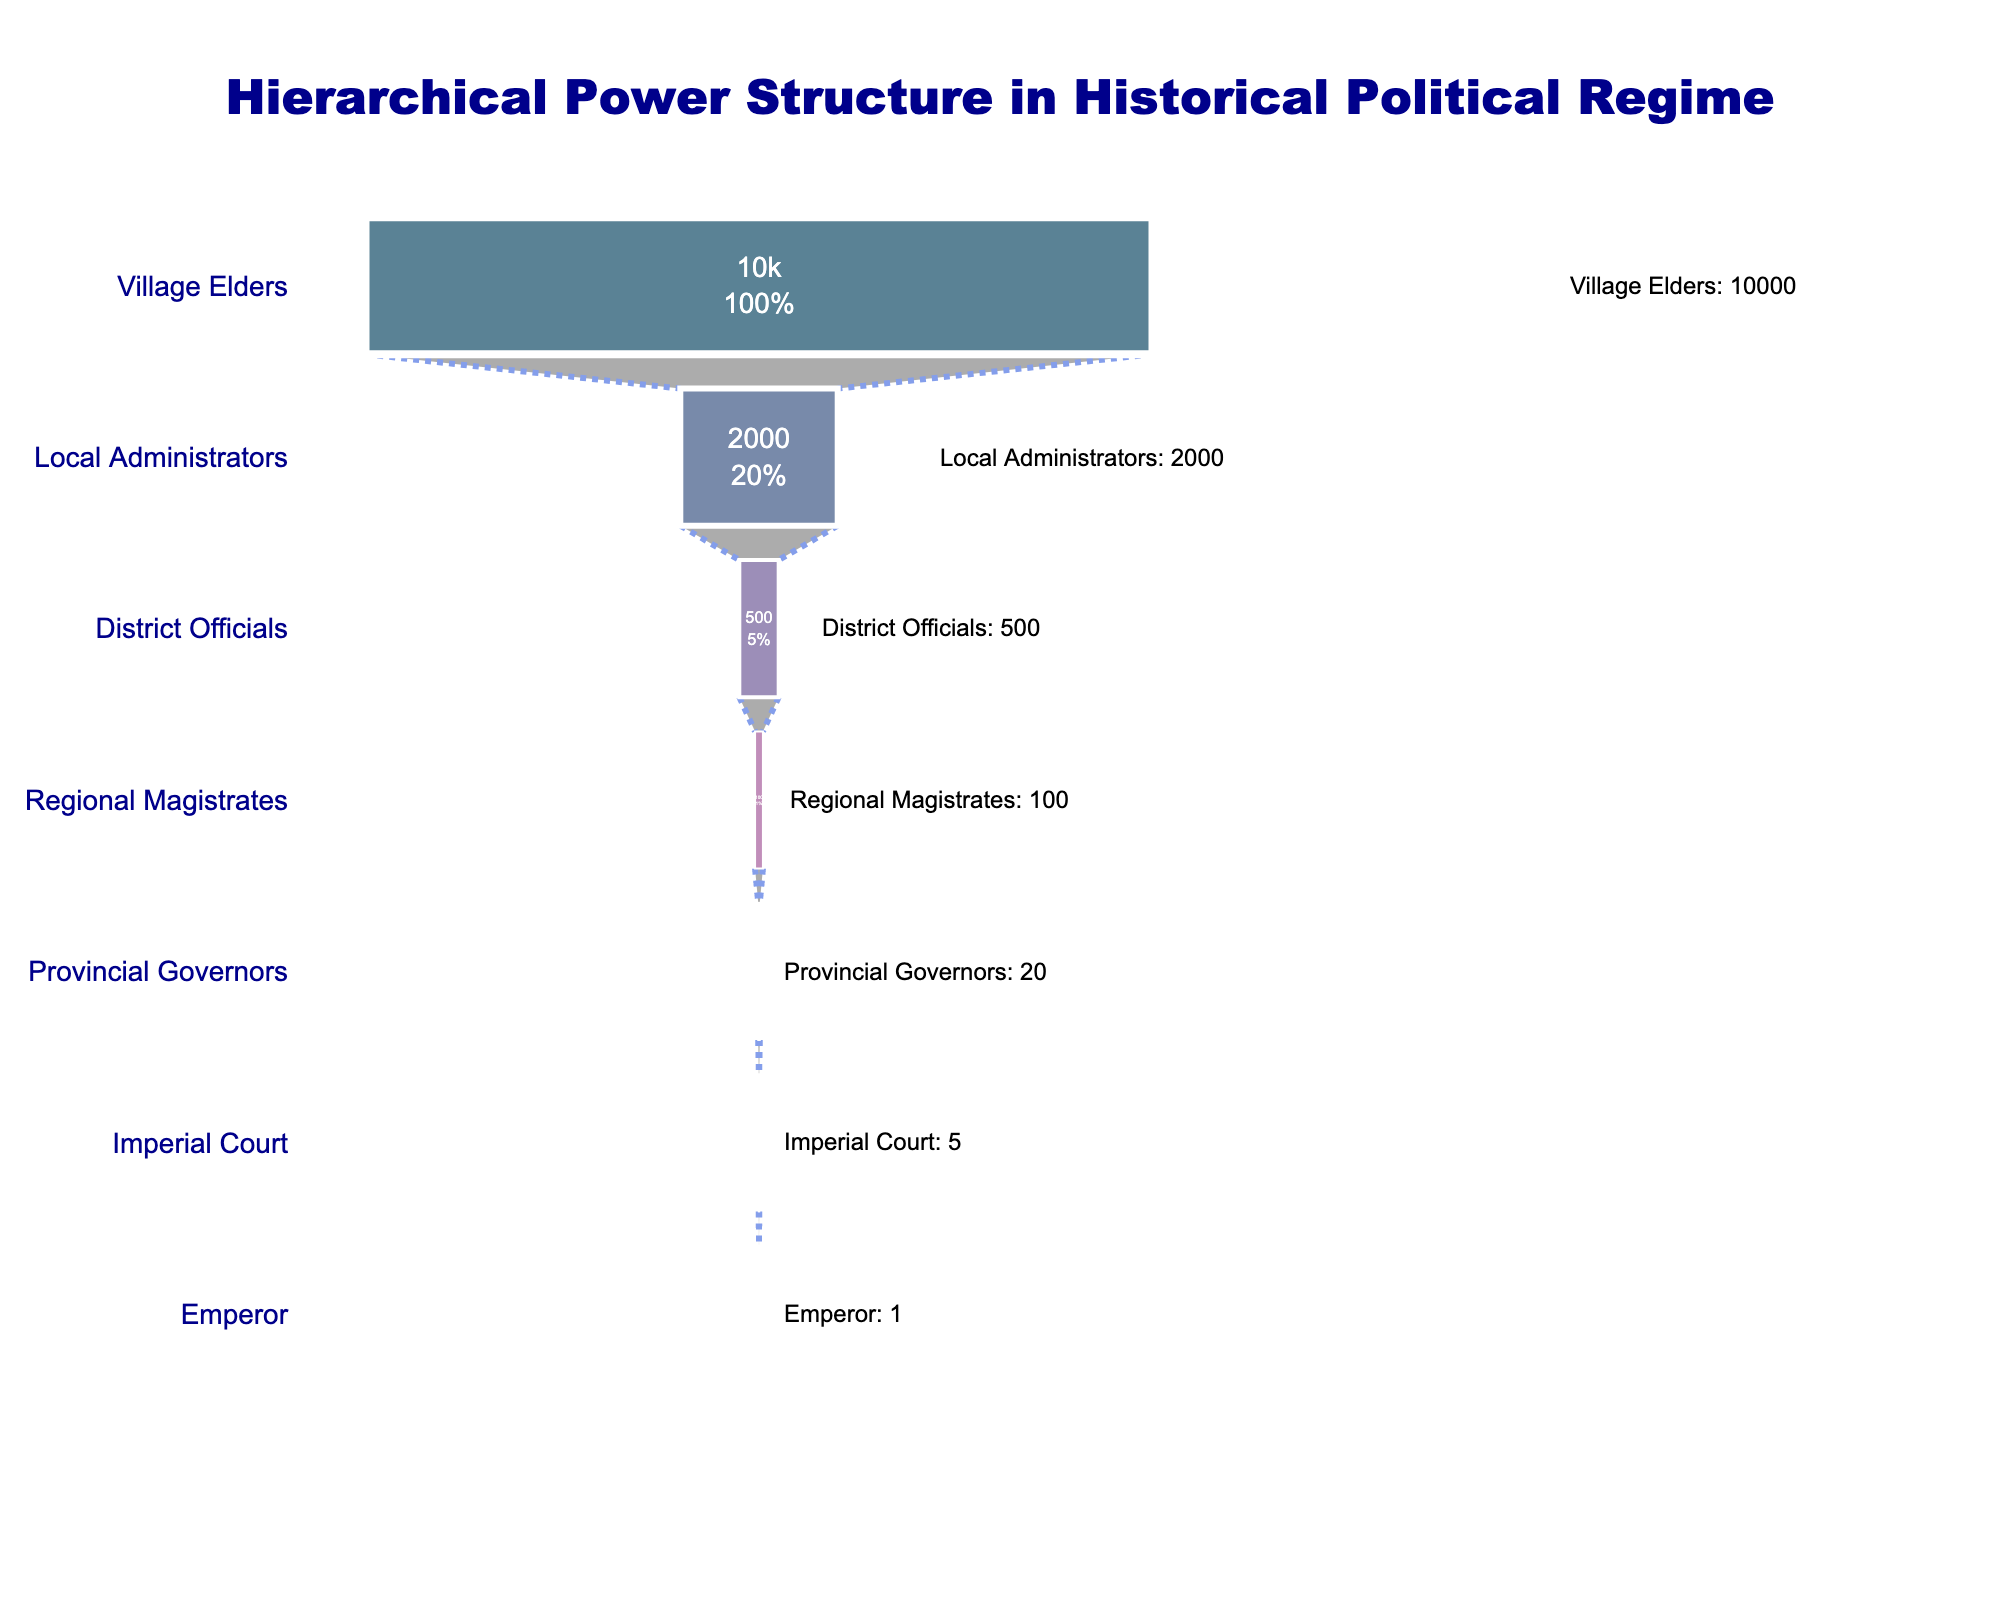How many levels are there in the hierarchical power structure? The title indicates that the plot represents a hierarchical power structure. By counting the distinct positions listed along the y-axis, we can ascertain the total number of levels. There are seven positions from Emperor to Village Elders.
Answer: 7 Which level has the highest number of individuals? By observing the funnel, the widest section at the bottom displays the highest number of individuals. This is the Village Elders level, which shows 10,000 individuals.
Answer: Village Elders What percentage of the total individuals does the Imperial Court represent? Starting from the top, note that the Imperial Court's section shows a percentage. Calculating this manually involves dividing the Imperial Court's 5 individuals by the total (sum of all levels: 12,626), then multiplying by 100.
Answer: 0.04% How many more District Officials are there compared to Regional Magistrates? Compare the numbers for District Officials (500) and Regional Magistrates (100) by subtracting the number of Regional Magistrates from District Officials. This results in 500 - 100 = 400.
Answer: 400 Which level has more individuals: Provincial Governors or Local Administrators? From the graphical depiction, the width of the respective sections and annotated numbers show that Local Administrators (2,000) outnumber Provincial Governors (20).
Answer: Local Administrators What is the sum of individuals from the Emperor to the Imperial Court inclusive? Adding the number of individuals in the Emperor (1) and the Imperial Court (5) levels results in 1 + 5 = 6.
Answer: 6 How many individuals are there between the Provincial Governors and the District Officials combined? Adding the individuals at the Provincial Governors (20), Regional Magistrates (100), and District Officials (500) results in 20 + 100 + 500 = 620.
Answer: 620 Which position represents the smallest percentage of the total hierarchical structure? The narrowest segment at the top, which is the Emperor with only 1 individual, makes up the smallest percentage.
Answer: Emperor How do the number of Provincial Governors compare relative to the number of Local Administrators by ratio? To find the ratio, divide the number of Provincial Governors (20) by the number of Local Administrators (2,000). This results in a ratio of 20/2000 = 1/100 or 1:100.
Answer: 1:100 What percentage of the overall number does the bottom three levels (District Officials, Local Administrators, Village Elders) represent? Calculate the sum of the individuals in District Officials (500), Local Administrators (2,000), and Village Elders (10,000) and then divide by the total number of individuals (12,626) and multiply by 100. So, (500 + 2,000 + 10,000) / 12,626 * 100 = ~97.97%.
Answer: 97.97% 